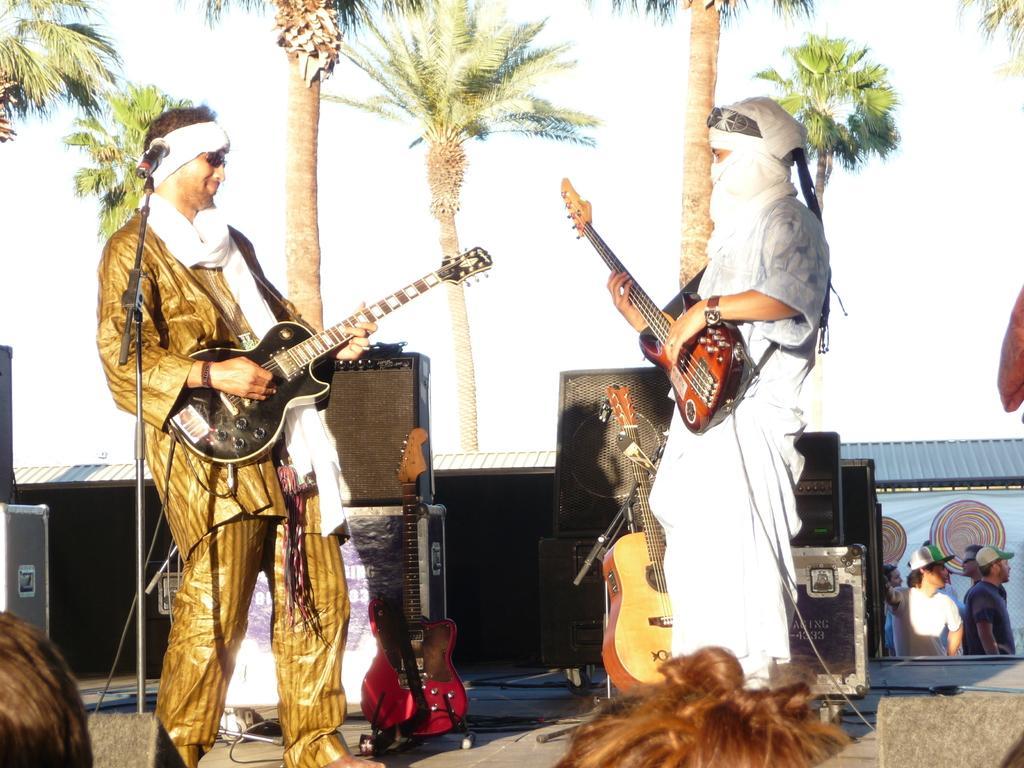Could you give a brief overview of what you see in this image? In this picture we can see two persons standing and they are playing guitar. On the background we can see some trees. And this is the sky and these are some musical instruments. 